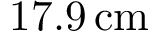Convert formula to latex. <formula><loc_0><loc_0><loc_500><loc_500>1 7 . 9 \, c m</formula> 